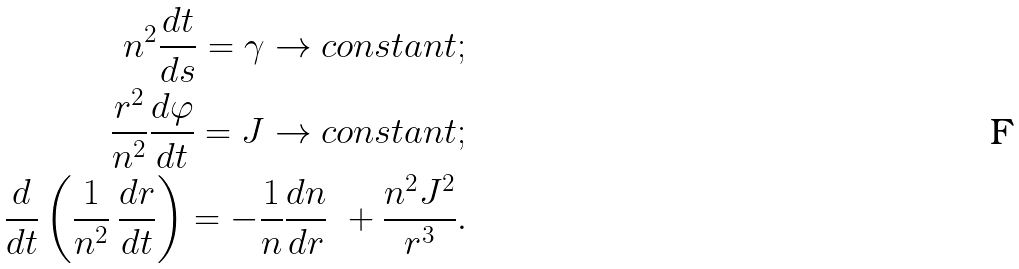Convert formula to latex. <formula><loc_0><loc_0><loc_500><loc_500>n ^ { 2 } \frac { d t } { d s } = \gamma \rightarrow c o n s t a n t ; \\ \frac { r ^ { 2 } } { n ^ { 2 } } \frac { d \varphi } { d t } = J \rightarrow c o n s t a n t ; \\ \frac { d } { d t } \left ( \frac { 1 } { n ^ { 2 } } \, \frac { d r } { d t } \right ) = - \frac { 1 } { n } \frac { d n } { d r } \ + \frac { n ^ { 2 } J ^ { 2 } } { r ^ { 3 } } .</formula> 